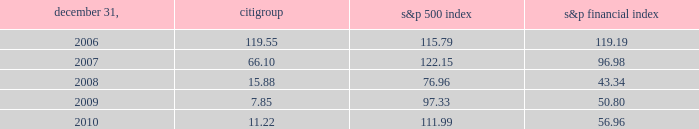Dividends for a summary of the cash dividends paid on citi 2019s outstanding common stock during 2009 and 2010 , see note 33 to the consolidated financial statements .
For so long as the u.s .
Government holds any citigroup trust preferred securities acquired pursuant to the exchange offers consummated in 2009 , citigroup has agreed not to pay a quarterly common stock dividend exceeding $ 0.01 per quarter , subject to certain customary exceptions .
Further , any dividend on citi 2019s outstanding common stock would need to be made in compliance with citi 2019s obligations to any remaining outstanding citigroup preferred stock .
Performance graph comparison of five-year cumulative total return the following graph and table compare the cumulative total return on citigroup 2019s common stock with the cumulative total return of the s&p 500 index and the s&p financial index over the five-year period extending through december 31 , 2010 .
The graph and table assume that $ 100 was invested on december 31 , 2005 in citigroup 2019s common stock , the s&p 500 index and the s&p financial index and that all dividends were reinvested .
Citigroup s&p 500 index s&p financial index comparison of five-year cumulative total return for the years ended 2006 2007 2008 2009 2010 .

In 2007 what was the ratio of the cumulative total return for citigroup to s&p 500 index? 
Rationale: in 2007 there was $ 0.54 of the cumulative total return for citigroup for each $ 1 of s&p 500 index
Computations: (66.10 / 122.15)
Answer: 0.54114. 